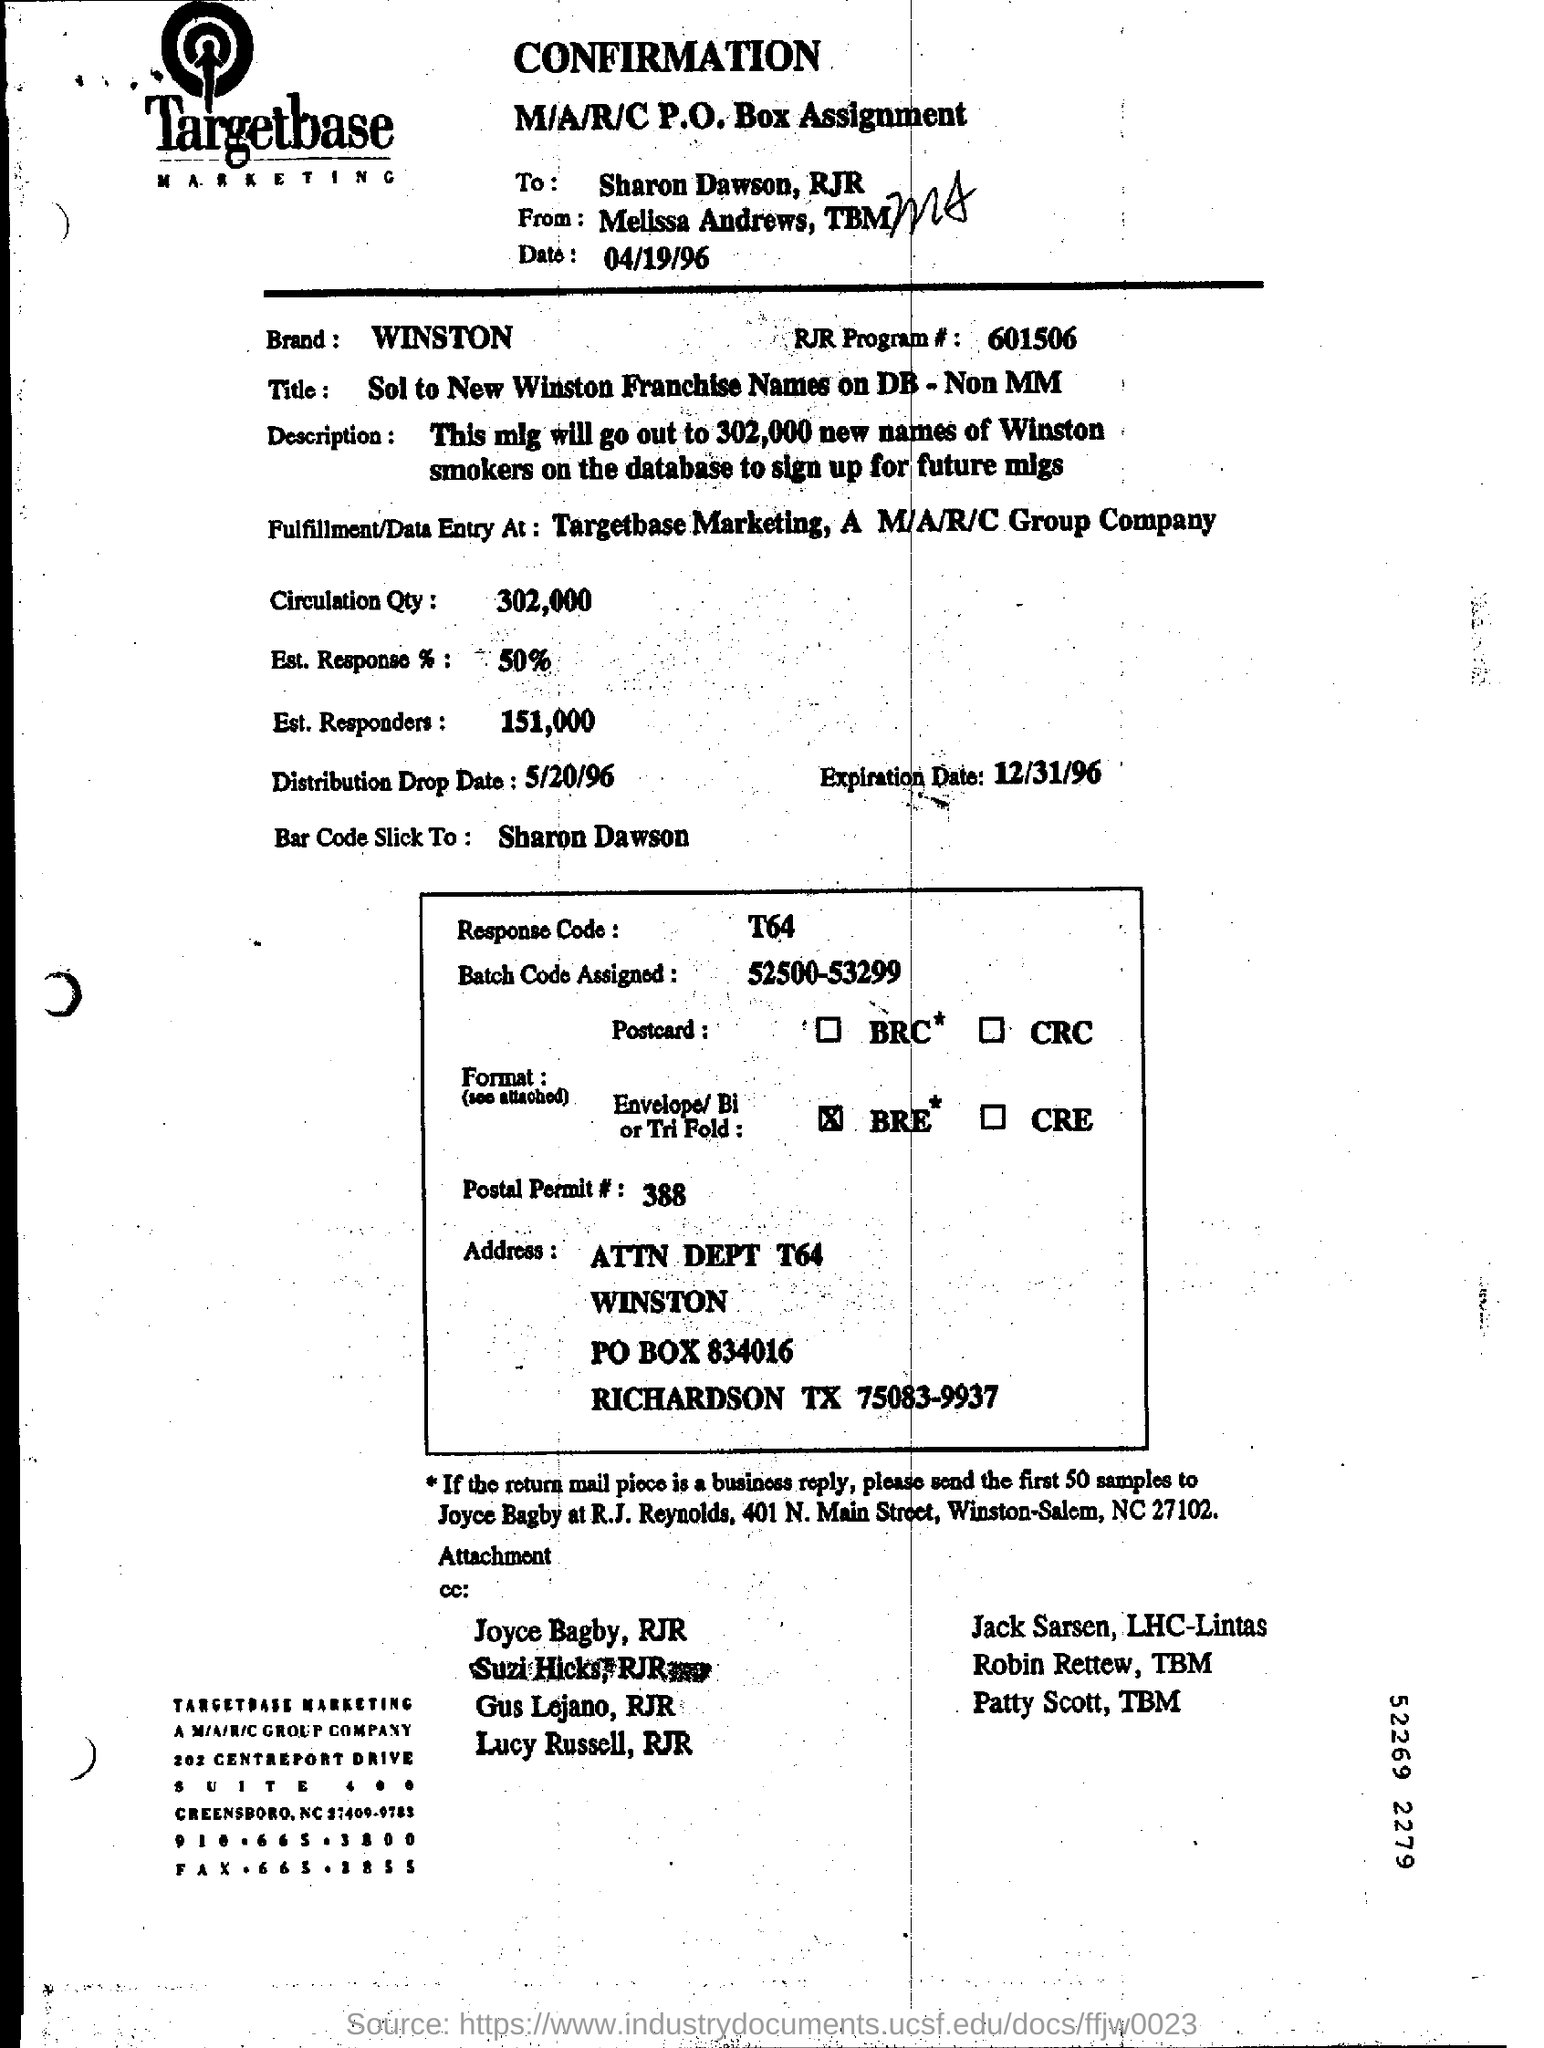Can you tell me the expiration date of the offer? The expiration date for the offer is December 31, 1996. 